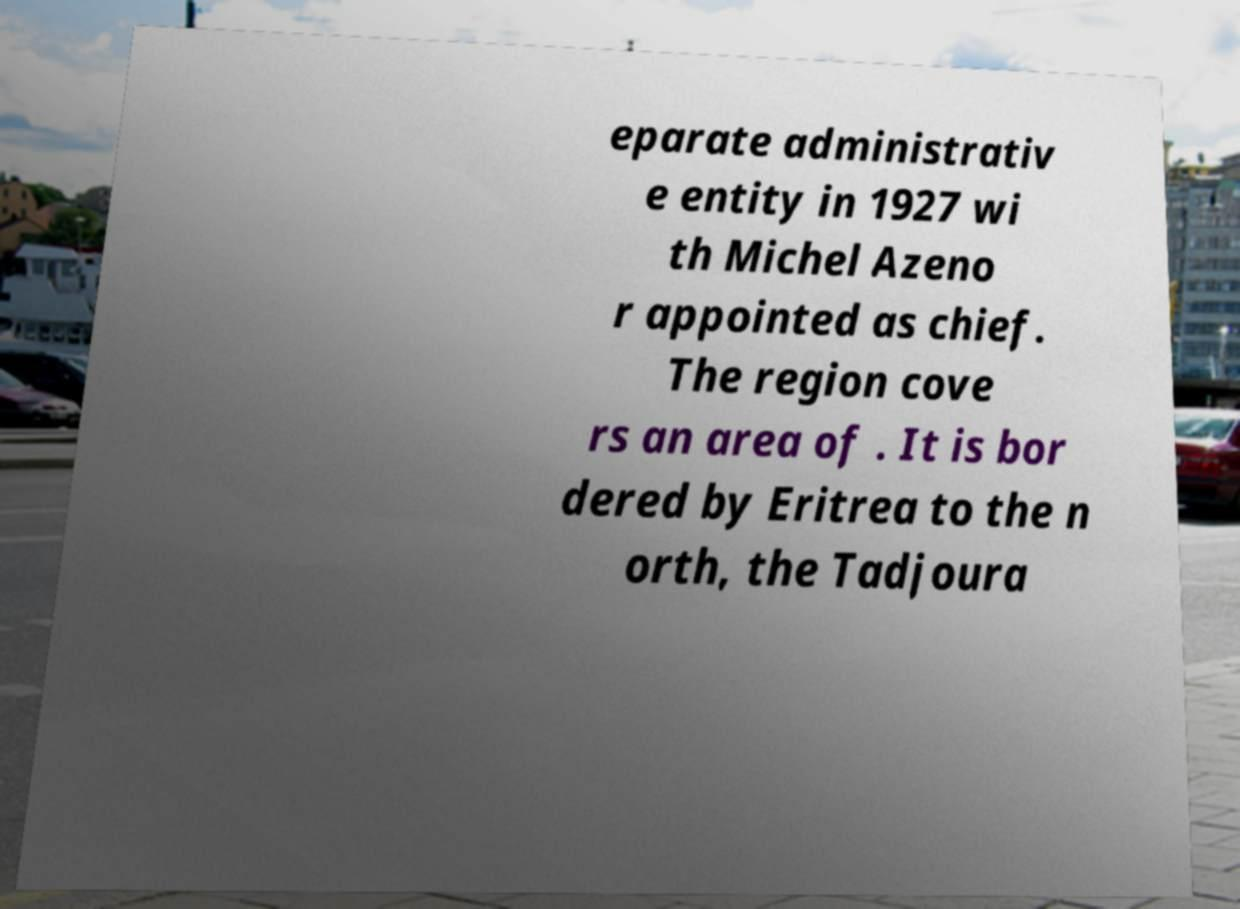Could you assist in decoding the text presented in this image and type it out clearly? eparate administrativ e entity in 1927 wi th Michel Azeno r appointed as chief. The region cove rs an area of . It is bor dered by Eritrea to the n orth, the Tadjoura 